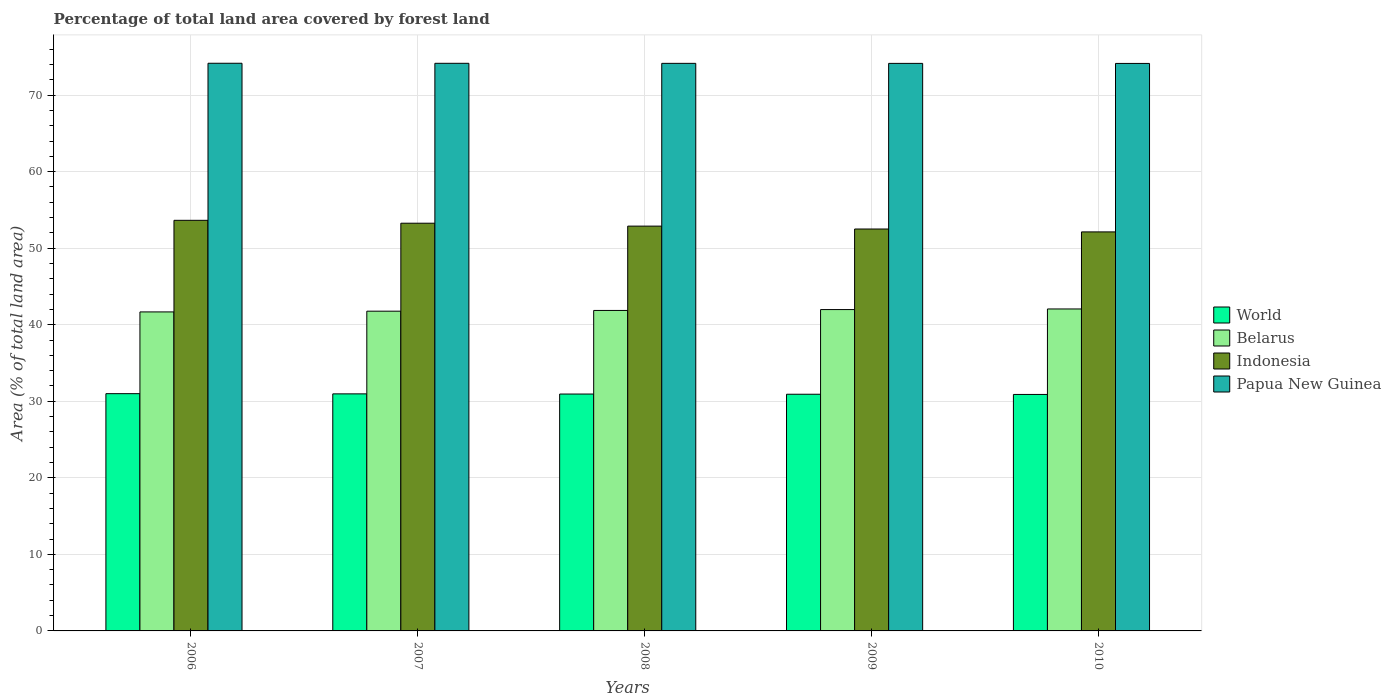How many different coloured bars are there?
Ensure brevity in your answer.  4. How many groups of bars are there?
Make the answer very short. 5. Are the number of bars on each tick of the X-axis equal?
Provide a short and direct response. Yes. How many bars are there on the 5th tick from the left?
Make the answer very short. 4. In how many cases, is the number of bars for a given year not equal to the number of legend labels?
Make the answer very short. 0. What is the percentage of forest land in Papua New Guinea in 2006?
Provide a short and direct response. 74.16. Across all years, what is the maximum percentage of forest land in Belarus?
Provide a short and direct response. 42.06. Across all years, what is the minimum percentage of forest land in Papua New Guinea?
Your response must be concise. 74.14. In which year was the percentage of forest land in Belarus maximum?
Your answer should be very brief. 2010. What is the total percentage of forest land in Belarus in the graph?
Ensure brevity in your answer.  209.35. What is the difference between the percentage of forest land in Belarus in 2006 and that in 2008?
Give a very brief answer. -0.19. What is the difference between the percentage of forest land in Indonesia in 2007 and the percentage of forest land in World in 2006?
Offer a terse response. 22.27. What is the average percentage of forest land in Belarus per year?
Give a very brief answer. 41.87. In the year 2007, what is the difference between the percentage of forest land in Papua New Guinea and percentage of forest land in Belarus?
Offer a very short reply. 32.38. What is the ratio of the percentage of forest land in World in 2006 to that in 2008?
Offer a very short reply. 1. What is the difference between the highest and the second highest percentage of forest land in Indonesia?
Provide a short and direct response. 0.38. What is the difference between the highest and the lowest percentage of forest land in Indonesia?
Provide a succinct answer. 1.51. In how many years, is the percentage of forest land in Indonesia greater than the average percentage of forest land in Indonesia taken over all years?
Your response must be concise. 3. Is it the case that in every year, the sum of the percentage of forest land in World and percentage of forest land in Indonesia is greater than the sum of percentage of forest land in Belarus and percentage of forest land in Papua New Guinea?
Your answer should be very brief. No. What does the 2nd bar from the left in 2008 represents?
Provide a short and direct response. Belarus. Are all the bars in the graph horizontal?
Give a very brief answer. No. What is the difference between two consecutive major ticks on the Y-axis?
Ensure brevity in your answer.  10. Does the graph contain any zero values?
Offer a very short reply. No. How many legend labels are there?
Your answer should be compact. 4. What is the title of the graph?
Provide a succinct answer. Percentage of total land area covered by forest land. What is the label or title of the X-axis?
Offer a very short reply. Years. What is the label or title of the Y-axis?
Keep it short and to the point. Area (% of total land area). What is the Area (% of total land area) in World in 2006?
Ensure brevity in your answer.  30.99. What is the Area (% of total land area) in Belarus in 2006?
Keep it short and to the point. 41.67. What is the Area (% of total land area) of Indonesia in 2006?
Ensure brevity in your answer.  53.64. What is the Area (% of total land area) in Papua New Guinea in 2006?
Your response must be concise. 74.16. What is the Area (% of total land area) in World in 2007?
Ensure brevity in your answer.  30.97. What is the Area (% of total land area) of Belarus in 2007?
Your response must be concise. 41.77. What is the Area (% of total land area) in Indonesia in 2007?
Your answer should be compact. 53.26. What is the Area (% of total land area) in Papua New Guinea in 2007?
Keep it short and to the point. 74.15. What is the Area (% of total land area) of World in 2008?
Ensure brevity in your answer.  30.95. What is the Area (% of total land area) in Belarus in 2008?
Make the answer very short. 41.87. What is the Area (% of total land area) in Indonesia in 2008?
Your answer should be compact. 52.88. What is the Area (% of total land area) of Papua New Guinea in 2008?
Your answer should be compact. 74.15. What is the Area (% of total land area) of World in 2009?
Your response must be concise. 30.92. What is the Area (% of total land area) of Belarus in 2009?
Your answer should be very brief. 41.98. What is the Area (% of total land area) in Indonesia in 2009?
Keep it short and to the point. 52.51. What is the Area (% of total land area) of Papua New Guinea in 2009?
Your answer should be compact. 74.14. What is the Area (% of total land area) of World in 2010?
Give a very brief answer. 30.89. What is the Area (% of total land area) in Belarus in 2010?
Offer a terse response. 42.06. What is the Area (% of total land area) in Indonesia in 2010?
Offer a terse response. 52.13. What is the Area (% of total land area) of Papua New Guinea in 2010?
Provide a short and direct response. 74.14. Across all years, what is the maximum Area (% of total land area) of World?
Your response must be concise. 30.99. Across all years, what is the maximum Area (% of total land area) in Belarus?
Give a very brief answer. 42.06. Across all years, what is the maximum Area (% of total land area) in Indonesia?
Offer a very short reply. 53.64. Across all years, what is the maximum Area (% of total land area) in Papua New Guinea?
Offer a very short reply. 74.16. Across all years, what is the minimum Area (% of total land area) in World?
Offer a very short reply. 30.89. Across all years, what is the minimum Area (% of total land area) of Belarus?
Provide a succinct answer. 41.67. Across all years, what is the minimum Area (% of total land area) of Indonesia?
Your answer should be very brief. 52.13. Across all years, what is the minimum Area (% of total land area) in Papua New Guinea?
Ensure brevity in your answer.  74.14. What is the total Area (% of total land area) in World in the graph?
Offer a very short reply. 154.72. What is the total Area (% of total land area) of Belarus in the graph?
Provide a succinct answer. 209.35. What is the total Area (% of total land area) in Indonesia in the graph?
Your answer should be very brief. 264.42. What is the total Area (% of total land area) of Papua New Guinea in the graph?
Provide a short and direct response. 370.73. What is the difference between the Area (% of total land area) in World in 2006 and that in 2007?
Your answer should be compact. 0.03. What is the difference between the Area (% of total land area) in Belarus in 2006 and that in 2007?
Your answer should be compact. -0.1. What is the difference between the Area (% of total land area) of Indonesia in 2006 and that in 2007?
Your response must be concise. 0.38. What is the difference between the Area (% of total land area) in Papua New Guinea in 2006 and that in 2007?
Your answer should be very brief. 0.01. What is the difference between the Area (% of total land area) in World in 2006 and that in 2008?
Offer a terse response. 0.05. What is the difference between the Area (% of total land area) in Belarus in 2006 and that in 2008?
Your answer should be very brief. -0.19. What is the difference between the Area (% of total land area) in Indonesia in 2006 and that in 2008?
Offer a terse response. 0.76. What is the difference between the Area (% of total land area) in Papua New Guinea in 2006 and that in 2008?
Your response must be concise. 0.01. What is the difference between the Area (% of total land area) of World in 2006 and that in 2009?
Make the answer very short. 0.07. What is the difference between the Area (% of total land area) in Belarus in 2006 and that in 2009?
Provide a succinct answer. -0.31. What is the difference between the Area (% of total land area) in Indonesia in 2006 and that in 2009?
Keep it short and to the point. 1.13. What is the difference between the Area (% of total land area) of Papua New Guinea in 2006 and that in 2009?
Ensure brevity in your answer.  0.02. What is the difference between the Area (% of total land area) in World in 2006 and that in 2010?
Offer a terse response. 0.1. What is the difference between the Area (% of total land area) of Belarus in 2006 and that in 2010?
Your response must be concise. -0.39. What is the difference between the Area (% of total land area) of Indonesia in 2006 and that in 2010?
Give a very brief answer. 1.51. What is the difference between the Area (% of total land area) of Papua New Guinea in 2006 and that in 2010?
Offer a very short reply. 0.02. What is the difference between the Area (% of total land area) of World in 2007 and that in 2008?
Keep it short and to the point. 0.02. What is the difference between the Area (% of total land area) of Belarus in 2007 and that in 2008?
Offer a very short reply. -0.1. What is the difference between the Area (% of total land area) in Indonesia in 2007 and that in 2008?
Your answer should be very brief. 0.38. What is the difference between the Area (% of total land area) in Papua New Guinea in 2007 and that in 2008?
Your answer should be compact. 0.01. What is the difference between the Area (% of total land area) in World in 2007 and that in 2009?
Offer a very short reply. 0.05. What is the difference between the Area (% of total land area) of Belarus in 2007 and that in 2009?
Your answer should be compact. -0.21. What is the difference between the Area (% of total land area) of Indonesia in 2007 and that in 2009?
Provide a short and direct response. 0.76. What is the difference between the Area (% of total land area) of Papua New Guinea in 2007 and that in 2009?
Provide a succinct answer. 0.01. What is the difference between the Area (% of total land area) of World in 2007 and that in 2010?
Provide a succinct answer. 0.08. What is the difference between the Area (% of total land area) of Belarus in 2007 and that in 2010?
Your response must be concise. -0.29. What is the difference between the Area (% of total land area) in Indonesia in 2007 and that in 2010?
Give a very brief answer. 1.13. What is the difference between the Area (% of total land area) in Papua New Guinea in 2007 and that in 2010?
Give a very brief answer. 0.02. What is the difference between the Area (% of total land area) of World in 2008 and that in 2009?
Your answer should be compact. 0.03. What is the difference between the Area (% of total land area) in Belarus in 2008 and that in 2009?
Your response must be concise. -0.11. What is the difference between the Area (% of total land area) in Indonesia in 2008 and that in 2009?
Keep it short and to the point. 0.38. What is the difference between the Area (% of total land area) in Papua New Guinea in 2008 and that in 2009?
Give a very brief answer. 0.01. What is the difference between the Area (% of total land area) of World in 2008 and that in 2010?
Your answer should be compact. 0.05. What is the difference between the Area (% of total land area) of Belarus in 2008 and that in 2010?
Your answer should be very brief. -0.19. What is the difference between the Area (% of total land area) in Indonesia in 2008 and that in 2010?
Keep it short and to the point. 0.76. What is the difference between the Area (% of total land area) of Papua New Guinea in 2008 and that in 2010?
Your answer should be very brief. 0.01. What is the difference between the Area (% of total land area) in World in 2009 and that in 2010?
Your answer should be compact. 0.03. What is the difference between the Area (% of total land area) of Belarus in 2009 and that in 2010?
Offer a very short reply. -0.08. What is the difference between the Area (% of total land area) in Indonesia in 2009 and that in 2010?
Your answer should be very brief. 0.38. What is the difference between the Area (% of total land area) of Papua New Guinea in 2009 and that in 2010?
Your answer should be compact. 0.01. What is the difference between the Area (% of total land area) of World in 2006 and the Area (% of total land area) of Belarus in 2007?
Keep it short and to the point. -10.78. What is the difference between the Area (% of total land area) of World in 2006 and the Area (% of total land area) of Indonesia in 2007?
Give a very brief answer. -22.27. What is the difference between the Area (% of total land area) in World in 2006 and the Area (% of total land area) in Papua New Guinea in 2007?
Provide a succinct answer. -43.16. What is the difference between the Area (% of total land area) of Belarus in 2006 and the Area (% of total land area) of Indonesia in 2007?
Offer a terse response. -11.59. What is the difference between the Area (% of total land area) in Belarus in 2006 and the Area (% of total land area) in Papua New Guinea in 2007?
Ensure brevity in your answer.  -32.48. What is the difference between the Area (% of total land area) in Indonesia in 2006 and the Area (% of total land area) in Papua New Guinea in 2007?
Provide a short and direct response. -20.51. What is the difference between the Area (% of total land area) of World in 2006 and the Area (% of total land area) of Belarus in 2008?
Make the answer very short. -10.87. What is the difference between the Area (% of total land area) of World in 2006 and the Area (% of total land area) of Indonesia in 2008?
Your answer should be very brief. -21.89. What is the difference between the Area (% of total land area) in World in 2006 and the Area (% of total land area) in Papua New Guinea in 2008?
Offer a terse response. -43.15. What is the difference between the Area (% of total land area) of Belarus in 2006 and the Area (% of total land area) of Indonesia in 2008?
Offer a terse response. -11.21. What is the difference between the Area (% of total land area) of Belarus in 2006 and the Area (% of total land area) of Papua New Guinea in 2008?
Offer a terse response. -32.47. What is the difference between the Area (% of total land area) in Indonesia in 2006 and the Area (% of total land area) in Papua New Guinea in 2008?
Offer a terse response. -20.51. What is the difference between the Area (% of total land area) in World in 2006 and the Area (% of total land area) in Belarus in 2009?
Your answer should be very brief. -10.99. What is the difference between the Area (% of total land area) of World in 2006 and the Area (% of total land area) of Indonesia in 2009?
Provide a short and direct response. -21.51. What is the difference between the Area (% of total land area) in World in 2006 and the Area (% of total land area) in Papua New Guinea in 2009?
Make the answer very short. -43.15. What is the difference between the Area (% of total land area) of Belarus in 2006 and the Area (% of total land area) of Indonesia in 2009?
Your answer should be compact. -10.83. What is the difference between the Area (% of total land area) in Belarus in 2006 and the Area (% of total land area) in Papua New Guinea in 2009?
Offer a very short reply. -32.47. What is the difference between the Area (% of total land area) in Indonesia in 2006 and the Area (% of total land area) in Papua New Guinea in 2009?
Ensure brevity in your answer.  -20.5. What is the difference between the Area (% of total land area) in World in 2006 and the Area (% of total land area) in Belarus in 2010?
Your answer should be compact. -11.07. What is the difference between the Area (% of total land area) in World in 2006 and the Area (% of total land area) in Indonesia in 2010?
Ensure brevity in your answer.  -21.13. What is the difference between the Area (% of total land area) of World in 2006 and the Area (% of total land area) of Papua New Guinea in 2010?
Provide a succinct answer. -43.14. What is the difference between the Area (% of total land area) of Belarus in 2006 and the Area (% of total land area) of Indonesia in 2010?
Make the answer very short. -10.45. What is the difference between the Area (% of total land area) in Belarus in 2006 and the Area (% of total land area) in Papua New Guinea in 2010?
Make the answer very short. -32.46. What is the difference between the Area (% of total land area) of Indonesia in 2006 and the Area (% of total land area) of Papua New Guinea in 2010?
Provide a short and direct response. -20.5. What is the difference between the Area (% of total land area) in World in 2007 and the Area (% of total land area) in Belarus in 2008?
Ensure brevity in your answer.  -10.9. What is the difference between the Area (% of total land area) of World in 2007 and the Area (% of total land area) of Indonesia in 2008?
Your answer should be very brief. -21.92. What is the difference between the Area (% of total land area) in World in 2007 and the Area (% of total land area) in Papua New Guinea in 2008?
Provide a succinct answer. -43.18. What is the difference between the Area (% of total land area) of Belarus in 2007 and the Area (% of total land area) of Indonesia in 2008?
Your answer should be compact. -11.11. What is the difference between the Area (% of total land area) of Belarus in 2007 and the Area (% of total land area) of Papua New Guinea in 2008?
Your response must be concise. -32.38. What is the difference between the Area (% of total land area) of Indonesia in 2007 and the Area (% of total land area) of Papua New Guinea in 2008?
Provide a short and direct response. -20.89. What is the difference between the Area (% of total land area) in World in 2007 and the Area (% of total land area) in Belarus in 2009?
Make the answer very short. -11.01. What is the difference between the Area (% of total land area) of World in 2007 and the Area (% of total land area) of Indonesia in 2009?
Provide a succinct answer. -21.54. What is the difference between the Area (% of total land area) of World in 2007 and the Area (% of total land area) of Papua New Guinea in 2009?
Offer a very short reply. -43.17. What is the difference between the Area (% of total land area) of Belarus in 2007 and the Area (% of total land area) of Indonesia in 2009?
Ensure brevity in your answer.  -10.73. What is the difference between the Area (% of total land area) in Belarus in 2007 and the Area (% of total land area) in Papua New Guinea in 2009?
Offer a very short reply. -32.37. What is the difference between the Area (% of total land area) in Indonesia in 2007 and the Area (% of total land area) in Papua New Guinea in 2009?
Ensure brevity in your answer.  -20.88. What is the difference between the Area (% of total land area) of World in 2007 and the Area (% of total land area) of Belarus in 2010?
Offer a very short reply. -11.09. What is the difference between the Area (% of total land area) of World in 2007 and the Area (% of total land area) of Indonesia in 2010?
Make the answer very short. -21.16. What is the difference between the Area (% of total land area) of World in 2007 and the Area (% of total land area) of Papua New Guinea in 2010?
Ensure brevity in your answer.  -43.17. What is the difference between the Area (% of total land area) in Belarus in 2007 and the Area (% of total land area) in Indonesia in 2010?
Your response must be concise. -10.36. What is the difference between the Area (% of total land area) of Belarus in 2007 and the Area (% of total land area) of Papua New Guinea in 2010?
Offer a very short reply. -32.37. What is the difference between the Area (% of total land area) in Indonesia in 2007 and the Area (% of total land area) in Papua New Guinea in 2010?
Your answer should be compact. -20.87. What is the difference between the Area (% of total land area) in World in 2008 and the Area (% of total land area) in Belarus in 2009?
Make the answer very short. -11.03. What is the difference between the Area (% of total land area) in World in 2008 and the Area (% of total land area) in Indonesia in 2009?
Offer a very short reply. -21.56. What is the difference between the Area (% of total land area) of World in 2008 and the Area (% of total land area) of Papua New Guinea in 2009?
Provide a succinct answer. -43.2. What is the difference between the Area (% of total land area) in Belarus in 2008 and the Area (% of total land area) in Indonesia in 2009?
Keep it short and to the point. -10.64. What is the difference between the Area (% of total land area) of Belarus in 2008 and the Area (% of total land area) of Papua New Guinea in 2009?
Your answer should be very brief. -32.27. What is the difference between the Area (% of total land area) in Indonesia in 2008 and the Area (% of total land area) in Papua New Guinea in 2009?
Give a very brief answer. -21.26. What is the difference between the Area (% of total land area) of World in 2008 and the Area (% of total land area) of Belarus in 2010?
Keep it short and to the point. -11.11. What is the difference between the Area (% of total land area) of World in 2008 and the Area (% of total land area) of Indonesia in 2010?
Give a very brief answer. -21.18. What is the difference between the Area (% of total land area) of World in 2008 and the Area (% of total land area) of Papua New Guinea in 2010?
Give a very brief answer. -43.19. What is the difference between the Area (% of total land area) in Belarus in 2008 and the Area (% of total land area) in Indonesia in 2010?
Your answer should be very brief. -10.26. What is the difference between the Area (% of total land area) of Belarus in 2008 and the Area (% of total land area) of Papua New Guinea in 2010?
Ensure brevity in your answer.  -32.27. What is the difference between the Area (% of total land area) of Indonesia in 2008 and the Area (% of total land area) of Papua New Guinea in 2010?
Make the answer very short. -21.25. What is the difference between the Area (% of total land area) in World in 2009 and the Area (% of total land area) in Belarus in 2010?
Your answer should be very brief. -11.14. What is the difference between the Area (% of total land area) of World in 2009 and the Area (% of total land area) of Indonesia in 2010?
Your answer should be compact. -21.21. What is the difference between the Area (% of total land area) of World in 2009 and the Area (% of total land area) of Papua New Guinea in 2010?
Your answer should be very brief. -43.22. What is the difference between the Area (% of total land area) of Belarus in 2009 and the Area (% of total land area) of Indonesia in 2010?
Offer a terse response. -10.15. What is the difference between the Area (% of total land area) in Belarus in 2009 and the Area (% of total land area) in Papua New Guinea in 2010?
Provide a succinct answer. -32.16. What is the difference between the Area (% of total land area) in Indonesia in 2009 and the Area (% of total land area) in Papua New Guinea in 2010?
Provide a succinct answer. -21.63. What is the average Area (% of total land area) of World per year?
Provide a short and direct response. 30.94. What is the average Area (% of total land area) in Belarus per year?
Your answer should be very brief. 41.87. What is the average Area (% of total land area) in Indonesia per year?
Your answer should be compact. 52.88. What is the average Area (% of total land area) of Papua New Guinea per year?
Offer a terse response. 74.15. In the year 2006, what is the difference between the Area (% of total land area) of World and Area (% of total land area) of Belarus?
Your answer should be very brief. -10.68. In the year 2006, what is the difference between the Area (% of total land area) in World and Area (% of total land area) in Indonesia?
Your response must be concise. -22.65. In the year 2006, what is the difference between the Area (% of total land area) in World and Area (% of total land area) in Papua New Guinea?
Provide a succinct answer. -43.16. In the year 2006, what is the difference between the Area (% of total land area) of Belarus and Area (% of total land area) of Indonesia?
Ensure brevity in your answer.  -11.97. In the year 2006, what is the difference between the Area (% of total land area) in Belarus and Area (% of total land area) in Papua New Guinea?
Ensure brevity in your answer.  -32.48. In the year 2006, what is the difference between the Area (% of total land area) of Indonesia and Area (% of total land area) of Papua New Guinea?
Make the answer very short. -20.52. In the year 2007, what is the difference between the Area (% of total land area) of World and Area (% of total land area) of Belarus?
Your answer should be very brief. -10.8. In the year 2007, what is the difference between the Area (% of total land area) in World and Area (% of total land area) in Indonesia?
Give a very brief answer. -22.29. In the year 2007, what is the difference between the Area (% of total land area) in World and Area (% of total land area) in Papua New Guinea?
Make the answer very short. -43.18. In the year 2007, what is the difference between the Area (% of total land area) in Belarus and Area (% of total land area) in Indonesia?
Your answer should be compact. -11.49. In the year 2007, what is the difference between the Area (% of total land area) in Belarus and Area (% of total land area) in Papua New Guinea?
Provide a succinct answer. -32.38. In the year 2007, what is the difference between the Area (% of total land area) in Indonesia and Area (% of total land area) in Papua New Guinea?
Offer a very short reply. -20.89. In the year 2008, what is the difference between the Area (% of total land area) of World and Area (% of total land area) of Belarus?
Your response must be concise. -10.92. In the year 2008, what is the difference between the Area (% of total land area) in World and Area (% of total land area) in Indonesia?
Offer a very short reply. -21.94. In the year 2008, what is the difference between the Area (% of total land area) of World and Area (% of total land area) of Papua New Guinea?
Provide a succinct answer. -43.2. In the year 2008, what is the difference between the Area (% of total land area) of Belarus and Area (% of total land area) of Indonesia?
Offer a very short reply. -11.02. In the year 2008, what is the difference between the Area (% of total land area) of Belarus and Area (% of total land area) of Papua New Guinea?
Provide a succinct answer. -32.28. In the year 2008, what is the difference between the Area (% of total land area) in Indonesia and Area (% of total land area) in Papua New Guinea?
Your response must be concise. -21.26. In the year 2009, what is the difference between the Area (% of total land area) of World and Area (% of total land area) of Belarus?
Your answer should be compact. -11.06. In the year 2009, what is the difference between the Area (% of total land area) of World and Area (% of total land area) of Indonesia?
Keep it short and to the point. -21.59. In the year 2009, what is the difference between the Area (% of total land area) in World and Area (% of total land area) in Papua New Guinea?
Offer a very short reply. -43.22. In the year 2009, what is the difference between the Area (% of total land area) of Belarus and Area (% of total land area) of Indonesia?
Offer a terse response. -10.53. In the year 2009, what is the difference between the Area (% of total land area) of Belarus and Area (% of total land area) of Papua New Guinea?
Provide a short and direct response. -32.16. In the year 2009, what is the difference between the Area (% of total land area) in Indonesia and Area (% of total land area) in Papua New Guinea?
Provide a succinct answer. -21.64. In the year 2010, what is the difference between the Area (% of total land area) of World and Area (% of total land area) of Belarus?
Your answer should be very brief. -11.17. In the year 2010, what is the difference between the Area (% of total land area) of World and Area (% of total land area) of Indonesia?
Keep it short and to the point. -21.23. In the year 2010, what is the difference between the Area (% of total land area) in World and Area (% of total land area) in Papua New Guinea?
Provide a succinct answer. -43.24. In the year 2010, what is the difference between the Area (% of total land area) of Belarus and Area (% of total land area) of Indonesia?
Ensure brevity in your answer.  -10.07. In the year 2010, what is the difference between the Area (% of total land area) of Belarus and Area (% of total land area) of Papua New Guinea?
Your answer should be very brief. -32.08. In the year 2010, what is the difference between the Area (% of total land area) of Indonesia and Area (% of total land area) of Papua New Guinea?
Offer a very short reply. -22.01. What is the ratio of the Area (% of total land area) of World in 2006 to that in 2007?
Ensure brevity in your answer.  1. What is the ratio of the Area (% of total land area) in Indonesia in 2006 to that in 2007?
Your answer should be compact. 1.01. What is the ratio of the Area (% of total land area) of Papua New Guinea in 2006 to that in 2007?
Offer a terse response. 1. What is the ratio of the Area (% of total land area) in World in 2006 to that in 2008?
Your response must be concise. 1. What is the ratio of the Area (% of total land area) in Indonesia in 2006 to that in 2008?
Your answer should be very brief. 1.01. What is the ratio of the Area (% of total land area) of Papua New Guinea in 2006 to that in 2008?
Provide a short and direct response. 1. What is the ratio of the Area (% of total land area) of World in 2006 to that in 2009?
Your response must be concise. 1. What is the ratio of the Area (% of total land area) in Belarus in 2006 to that in 2009?
Offer a terse response. 0.99. What is the ratio of the Area (% of total land area) in Indonesia in 2006 to that in 2009?
Ensure brevity in your answer.  1.02. What is the ratio of the Area (% of total land area) in Papua New Guinea in 2006 to that in 2009?
Offer a terse response. 1. What is the ratio of the Area (% of total land area) in Belarus in 2006 to that in 2010?
Your answer should be very brief. 0.99. What is the ratio of the Area (% of total land area) of Belarus in 2007 to that in 2008?
Keep it short and to the point. 1. What is the ratio of the Area (% of total land area) in World in 2007 to that in 2009?
Your answer should be very brief. 1. What is the ratio of the Area (% of total land area) in Belarus in 2007 to that in 2009?
Your answer should be very brief. 0.99. What is the ratio of the Area (% of total land area) of Indonesia in 2007 to that in 2009?
Your response must be concise. 1.01. What is the ratio of the Area (% of total land area) of World in 2007 to that in 2010?
Offer a terse response. 1. What is the ratio of the Area (% of total land area) in Belarus in 2007 to that in 2010?
Offer a terse response. 0.99. What is the ratio of the Area (% of total land area) in Indonesia in 2007 to that in 2010?
Ensure brevity in your answer.  1.02. What is the ratio of the Area (% of total land area) of Papua New Guinea in 2007 to that in 2010?
Keep it short and to the point. 1. What is the ratio of the Area (% of total land area) of World in 2008 to that in 2009?
Give a very brief answer. 1. What is the ratio of the Area (% of total land area) of Belarus in 2008 to that in 2009?
Your answer should be compact. 1. What is the ratio of the Area (% of total land area) in Papua New Guinea in 2008 to that in 2009?
Provide a succinct answer. 1. What is the ratio of the Area (% of total land area) of Belarus in 2008 to that in 2010?
Your answer should be very brief. 1. What is the ratio of the Area (% of total land area) of Indonesia in 2008 to that in 2010?
Offer a very short reply. 1.01. What is the ratio of the Area (% of total land area) in Indonesia in 2009 to that in 2010?
Keep it short and to the point. 1.01. What is the ratio of the Area (% of total land area) in Papua New Guinea in 2009 to that in 2010?
Keep it short and to the point. 1. What is the difference between the highest and the second highest Area (% of total land area) in World?
Offer a very short reply. 0.03. What is the difference between the highest and the second highest Area (% of total land area) of Belarus?
Provide a short and direct response. 0.08. What is the difference between the highest and the second highest Area (% of total land area) of Indonesia?
Offer a terse response. 0.38. What is the difference between the highest and the second highest Area (% of total land area) in Papua New Guinea?
Offer a terse response. 0.01. What is the difference between the highest and the lowest Area (% of total land area) in World?
Ensure brevity in your answer.  0.1. What is the difference between the highest and the lowest Area (% of total land area) of Belarus?
Provide a succinct answer. 0.39. What is the difference between the highest and the lowest Area (% of total land area) of Indonesia?
Provide a short and direct response. 1.51. What is the difference between the highest and the lowest Area (% of total land area) in Papua New Guinea?
Ensure brevity in your answer.  0.02. 